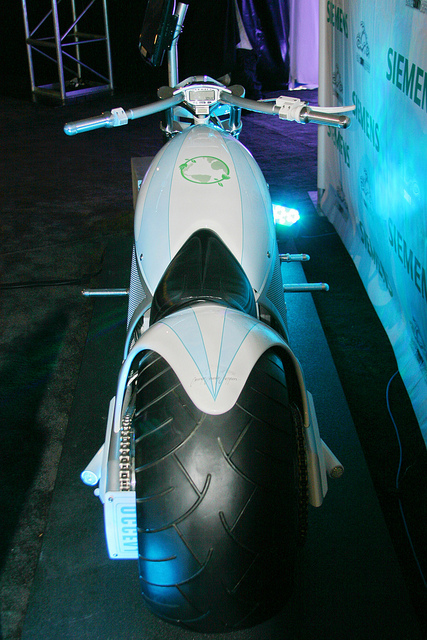Please identify all text content in this image. SIEME 